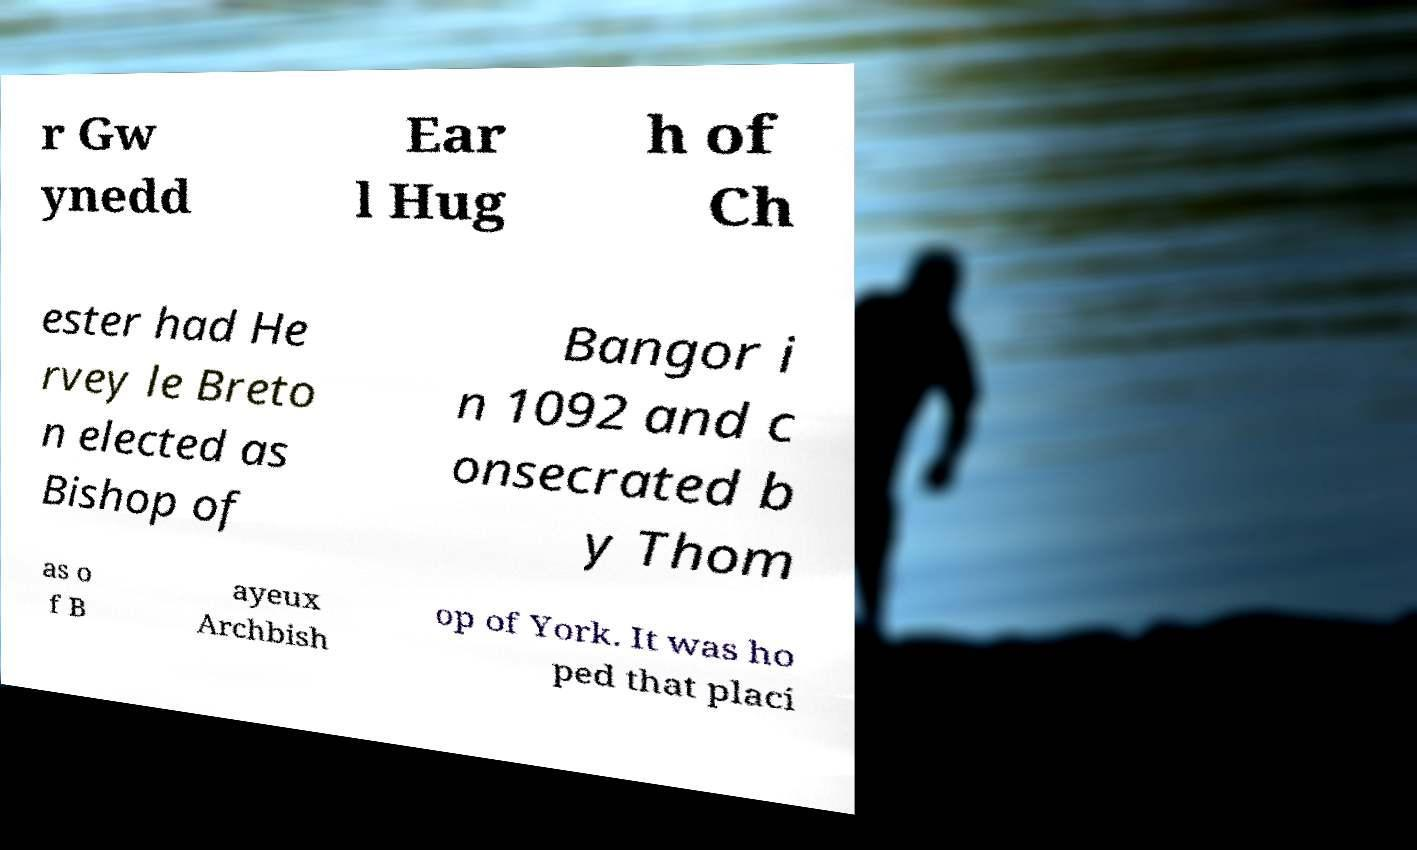What messages or text are displayed in this image? I need them in a readable, typed format. r Gw ynedd Ear l Hug h of Ch ester had He rvey le Breto n elected as Bishop of Bangor i n 1092 and c onsecrated b y Thom as o f B ayeux Archbish op of York. It was ho ped that placi 